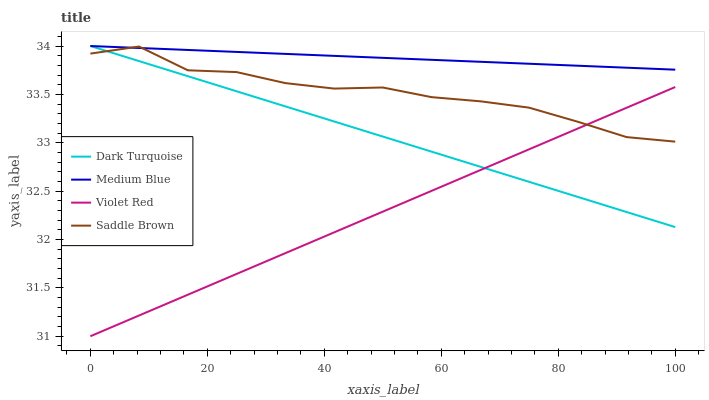Does Violet Red have the minimum area under the curve?
Answer yes or no. Yes. Does Medium Blue have the maximum area under the curve?
Answer yes or no. Yes. Does Medium Blue have the minimum area under the curve?
Answer yes or no. No. Does Violet Red have the maximum area under the curve?
Answer yes or no. No. Is Dark Turquoise the smoothest?
Answer yes or no. Yes. Is Saddle Brown the roughest?
Answer yes or no. Yes. Is Violet Red the smoothest?
Answer yes or no. No. Is Violet Red the roughest?
Answer yes or no. No. Does Violet Red have the lowest value?
Answer yes or no. Yes. Does Medium Blue have the lowest value?
Answer yes or no. No. Does Medium Blue have the highest value?
Answer yes or no. Yes. Does Violet Red have the highest value?
Answer yes or no. No. Is Violet Red less than Medium Blue?
Answer yes or no. Yes. Is Medium Blue greater than Violet Red?
Answer yes or no. Yes. Does Dark Turquoise intersect Violet Red?
Answer yes or no. Yes. Is Dark Turquoise less than Violet Red?
Answer yes or no. No. Is Dark Turquoise greater than Violet Red?
Answer yes or no. No. Does Violet Red intersect Medium Blue?
Answer yes or no. No. 